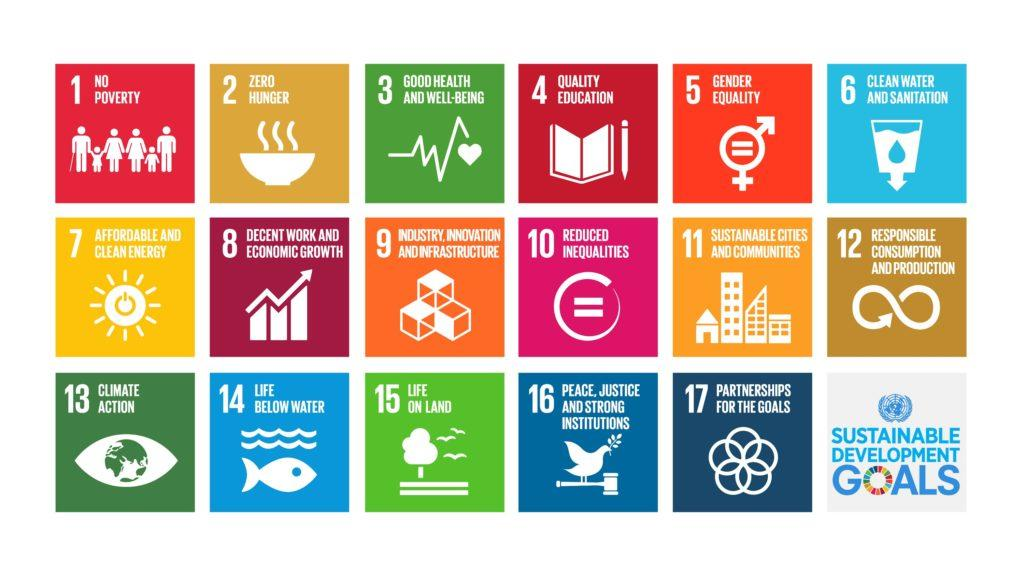Mention a couple of crucial points in this snapshot. The sustainable development goal that is defined by the cell in the second row and third column as "Industry, Innovation and Infrastructure" is a target that aims to promote sustainable industrialization and infrastructure development, increase access to clean energy and technology, and improve industrial design and production methods. How many goals are shown in the last row? There are 5 goals displayed. The goal that is defined by fish and water is life below water. The sustainable goal that is defined by the cell in the second row and first column as 'affordable and clean energy' is a key objective of the United Nations' sustainable development goals. The goal denoted by book and pencil is quality education. 